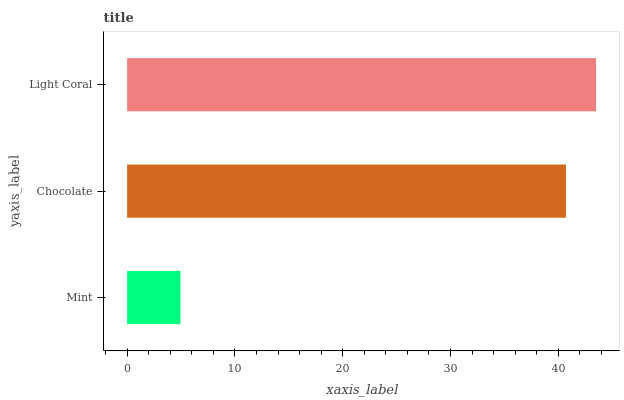Is Mint the minimum?
Answer yes or no. Yes. Is Light Coral the maximum?
Answer yes or no. Yes. Is Chocolate the minimum?
Answer yes or no. No. Is Chocolate the maximum?
Answer yes or no. No. Is Chocolate greater than Mint?
Answer yes or no. Yes. Is Mint less than Chocolate?
Answer yes or no. Yes. Is Mint greater than Chocolate?
Answer yes or no. No. Is Chocolate less than Mint?
Answer yes or no. No. Is Chocolate the high median?
Answer yes or no. Yes. Is Chocolate the low median?
Answer yes or no. Yes. Is Mint the high median?
Answer yes or no. No. Is Mint the low median?
Answer yes or no. No. 